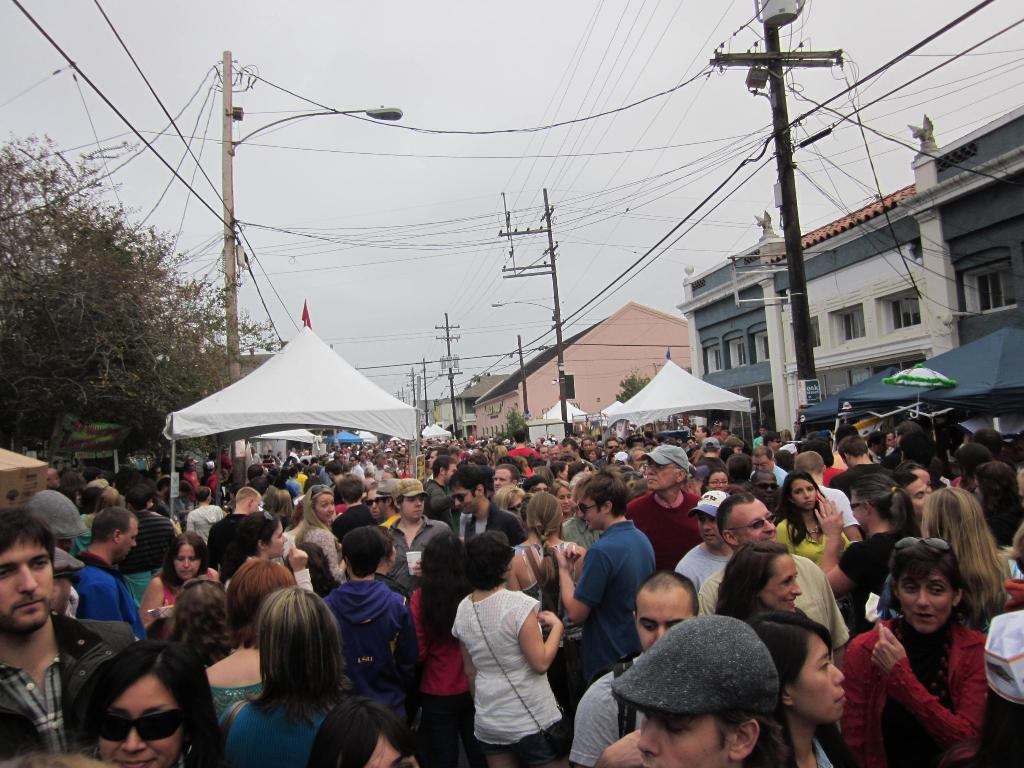What is the main feature of the image? The main feature of the image is a huge crowd. What structures can be seen among the crowd? There are tents in between the crowd. What other elements are present in the image? There are current poles, buildings, and trees on the left side of the image. What type of cakes are being baked in the oven in the image? There is no oven or cakes present in the image. How does the rain affect the crowd in the image? There is no rain present in the image, so its effect on the crowd cannot be determined. 